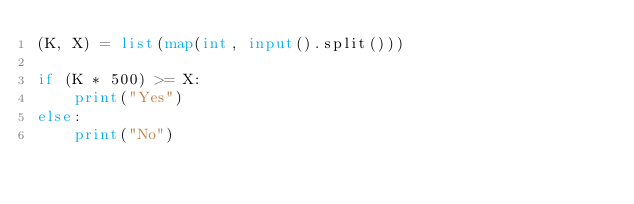<code> <loc_0><loc_0><loc_500><loc_500><_Python_>(K, X) = list(map(int, input().split()))

if (K * 500) >= X:
    print("Yes")
else:
    print("No")</code> 